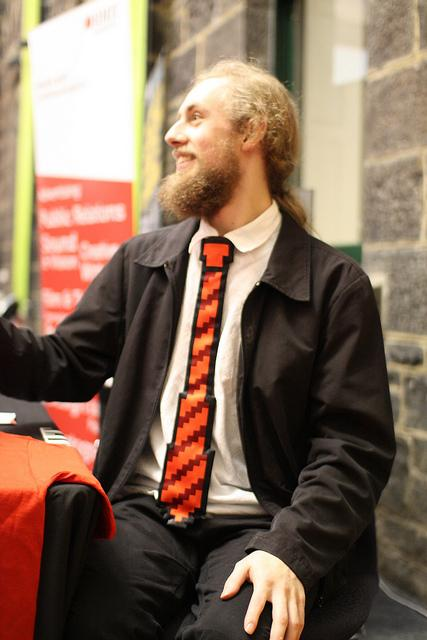What unusual design does his tie have?

Choices:
A) optical illusion
B) polka dots
C) like pixels
D) cartoons like pixels 